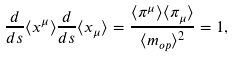<formula> <loc_0><loc_0><loc_500><loc_500>\frac { d } { d s } \langle x ^ { \mu } \rangle \frac { d } { d s } \langle x _ { \mu } \rangle = \frac { \langle \pi ^ { \mu } \rangle \langle \pi _ { \mu } \rangle } { \langle m _ { o p } \rangle ^ { 2 } } = 1 ,</formula> 